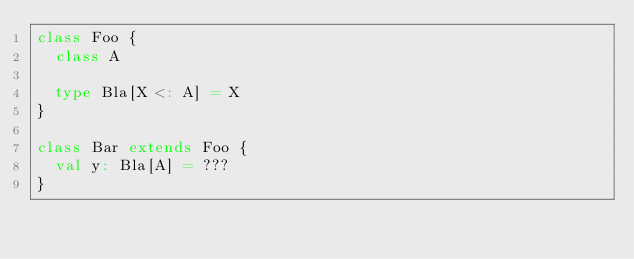<code> <loc_0><loc_0><loc_500><loc_500><_Scala_>class Foo {
  class A

  type Bla[X <: A] = X
}

class Bar extends Foo {
  val y: Bla[A] = ???
}
</code> 